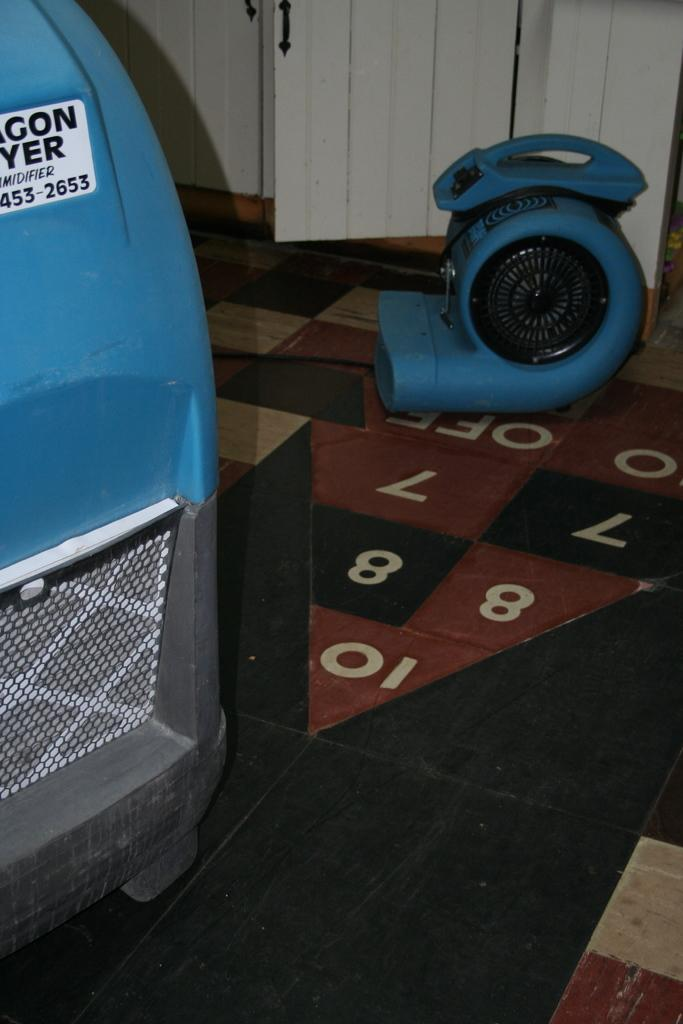What objects are on the floor in the image? There are two motors on the floor in the image. What can be seen in the image that might allow access to another area? There is a door visible in the image. What type of structure is visible in the image? There is a wall visible in the image. How many heads can be seen in the crowd in the image? There is no crowd present in the image, and therefore no heads can be seen. 